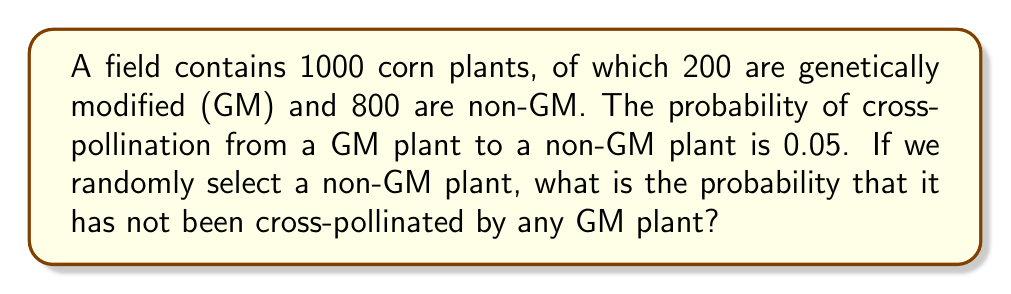Could you help me with this problem? Let's approach this step-by-step:

1) First, we need to calculate the probability that a single GM plant does not cross-pollinate our selected non-GM plant.
   This probability is $1 - 0.05 = 0.95$

2) For our selected non-GM plant to remain non-cross-pollinated, it must not be cross-pollinated by any of the 200 GM plants.

3) Assuming independence of cross-pollination events, we can use the multiplication rule of probability. The probability of all 200 events not occurring is:

   $$(0.95)^{200}$$

4) Let's calculate this:
   
   $$(0.95)^{200} \approx 3.5 \times 10^{-5}$$

5) Therefore, the probability that our randomly selected non-GM plant has not been cross-pollinated by any GM plant is approximately $3.5 \times 10^{-5}$ or 0.0035%.

This extremely low probability suggests that cross-pollination is highly likely in this scenario, which is crucial information for a regulatory analyst assessing the environmental impact of GM crops.
Answer: $3.5 \times 10^{-5}$ 